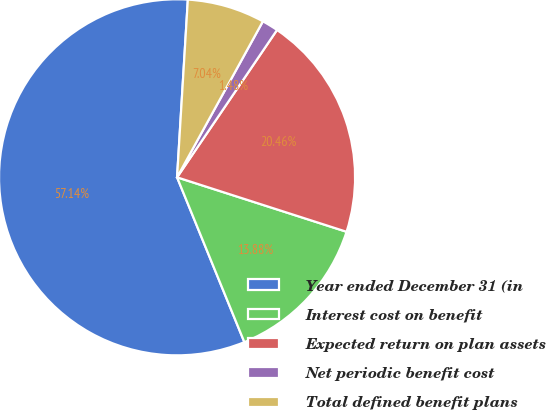Convert chart to OTSL. <chart><loc_0><loc_0><loc_500><loc_500><pie_chart><fcel>Year ended December 31 (in<fcel>Interest cost on benefit<fcel>Expected return on plan assets<fcel>Net periodic benefit cost<fcel>Total defined benefit plans<nl><fcel>57.13%<fcel>13.88%<fcel>20.46%<fcel>1.48%<fcel>7.04%<nl></chart> 